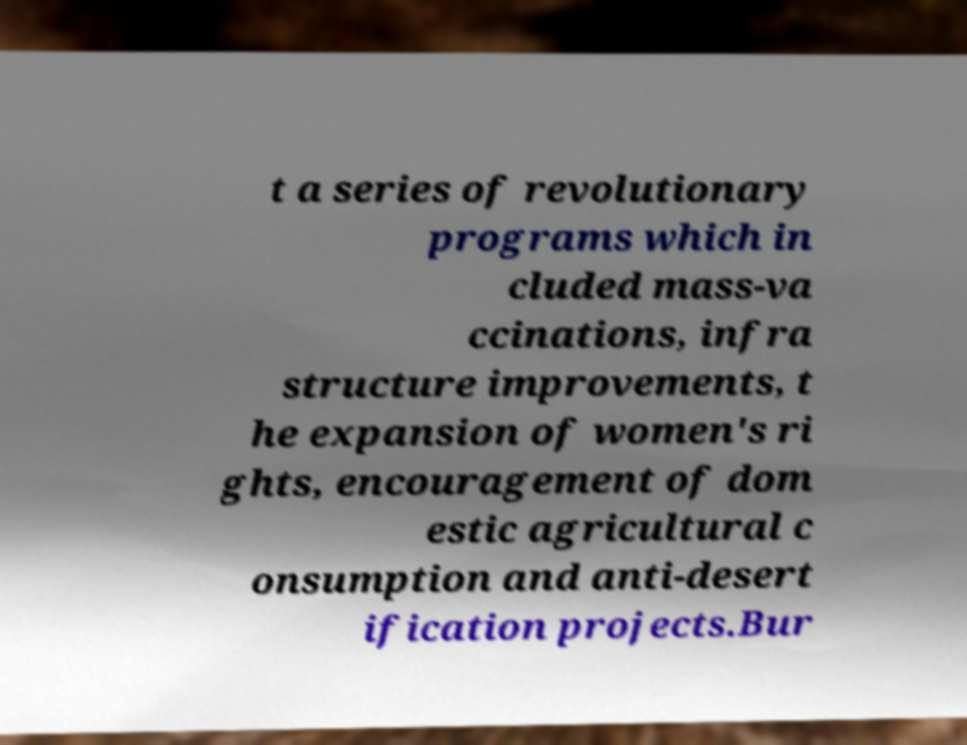Could you extract and type out the text from this image? t a series of revolutionary programs which in cluded mass-va ccinations, infra structure improvements, t he expansion of women's ri ghts, encouragement of dom estic agricultural c onsumption and anti-desert ification projects.Bur 